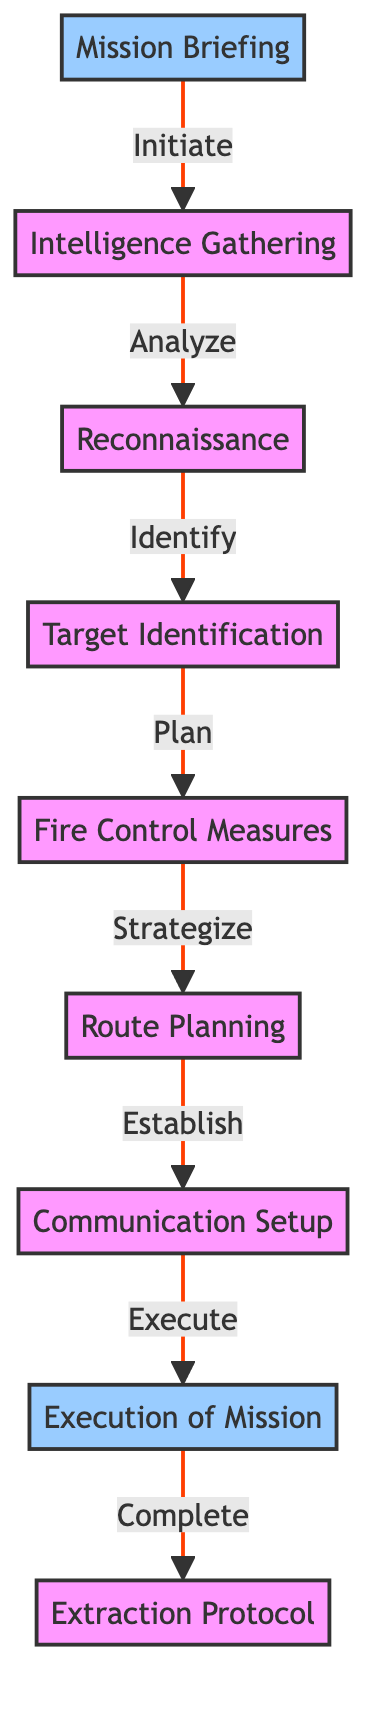What is the first step in the mission planning process? The first step is "Mission Briefing," which is represented as node 1 in the diagram. This node is connected to the next step, "Intelligence Gathering," signifying it as the starting point.
Answer: Mission Briefing How many nodes are present in the diagram? The diagram contains a total of 9 nodes, which represent various steps in the mission planning process. Each node correlates to different aspects of the mission from briefing to extraction.
Answer: 9 What follows "Reconnaissance" in the mission flow? "Target Identification" follows "Reconnaissance," shown by the directed edge connecting node 3 (Reconnaissance) to node 4 (Target Identification). This indicates the sequence of steps in the planning process.
Answer: Target Identification Which step precedes "Execution of Mission"? The step that precedes "Execution of Mission" is "Communication Setup," which is node 7. There is a directed edge from node 7 to node 8, demonstrating the flow of the mission.
Answer: Communication Setup What is the last step in the mission planning process? The last step in the process is "Extraction Protocol," which is represented as node 9. This is where the mission concludes after the execution.
Answer: Extraction Protocol How many directed edges are there in the diagram? There are a total of 8 directed edges in the diagram. Each edge represents the flow of steps from one node to another, indicating the order of operations in mission planning.
Answer: 8 Which node links "Fire Control Measures" to the next step? The node that links "Fire Control Measures" to the next step is "Route Planning," represented as node 6. The directed edge from node 5 to node 6 shows this connection in the diagram.
Answer: Route Planning What does "Intelligence Gathering" lead to according to the flowchart? "Intelligence Gathering" leads to "Reconnaissance," as indicated by the edge that connects node 2 (Intelligence Gathering) to node 3 (Reconnaissance). This denotes the sequential role of each step.
Answer: Reconnaissance Which step is associated with planning the route? The step associated with planning the route is "Route Planning," represented as node 6 in the diagram. This node is reached after completing "Fire Control Measures," shown by the edge from node 5.
Answer: Route Planning 